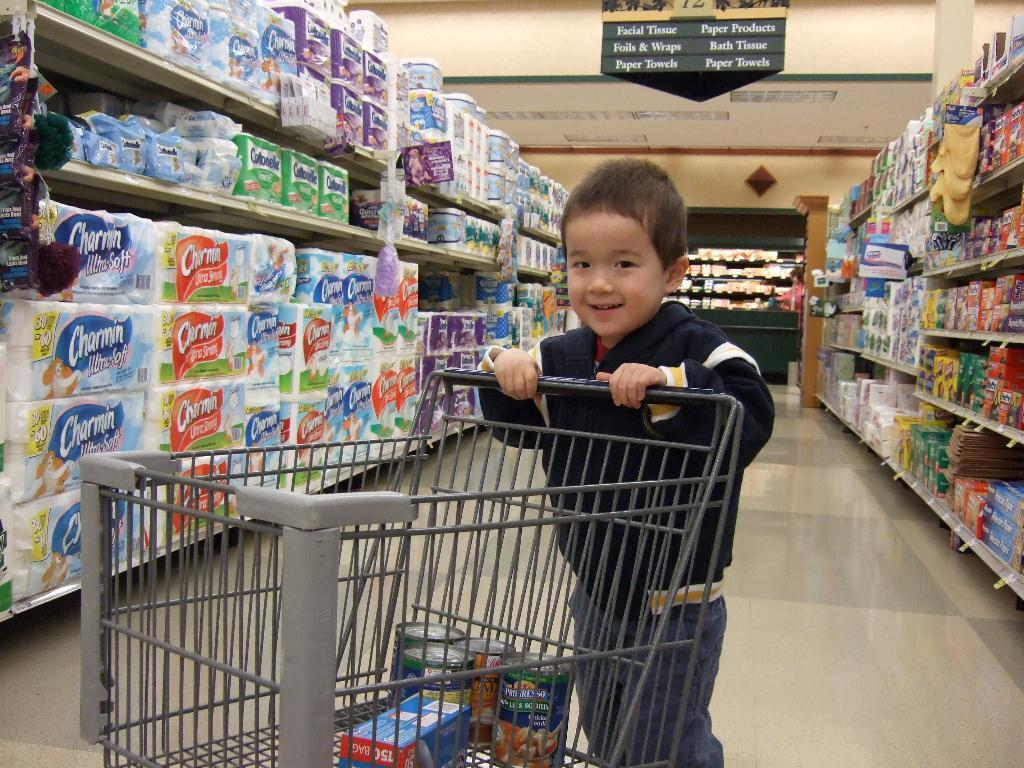<image>
Give a short and clear explanation of the subsequent image. A little boy pushes a shopping cart down an aisle, a few items including Progresso soup, in the cart. 